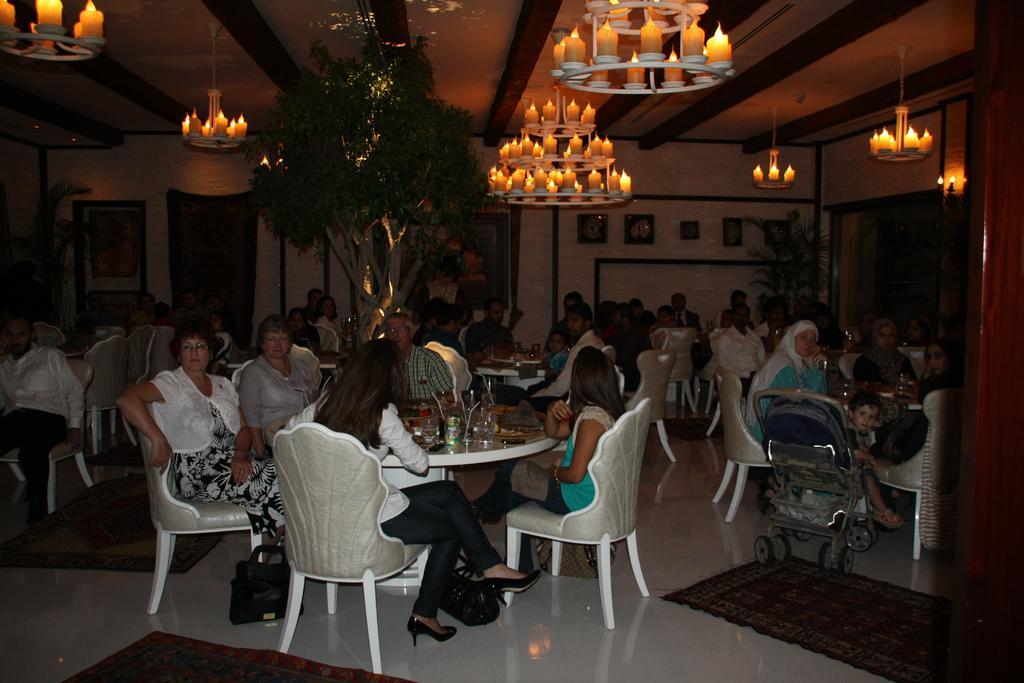In one or two sentences, can you explain what this image depicts? This is a hall. There are many tables around it there are chairs , people are sitting on it. On the middle there is a tree. On the top there are chandeliers. On the right there is a stroller. There are carpets on the floor. In the background there are paintings. 